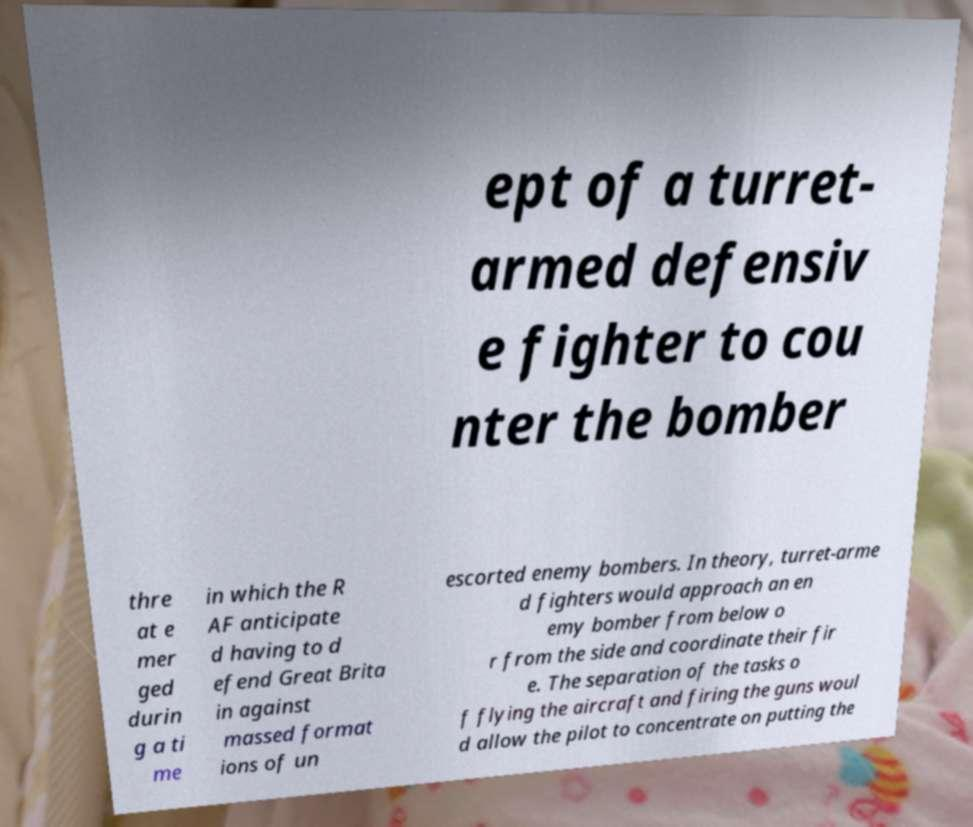Please read and relay the text visible in this image. What does it say? ept of a turret- armed defensiv e fighter to cou nter the bomber thre at e mer ged durin g a ti me in which the R AF anticipate d having to d efend Great Brita in against massed format ions of un escorted enemy bombers. In theory, turret-arme d fighters would approach an en emy bomber from below o r from the side and coordinate their fir e. The separation of the tasks o f flying the aircraft and firing the guns woul d allow the pilot to concentrate on putting the 